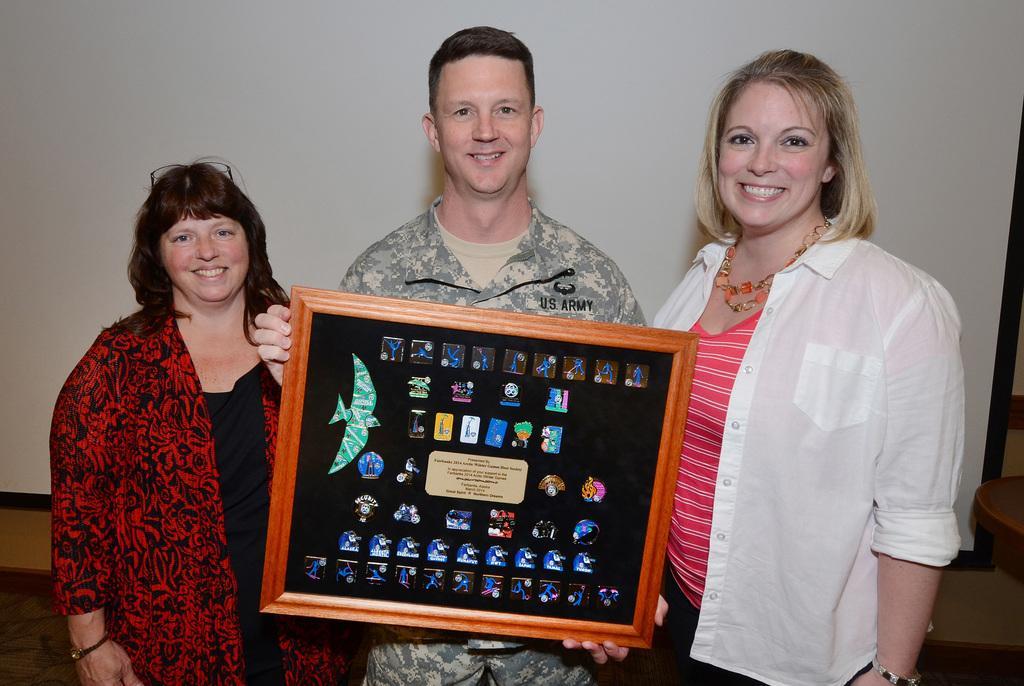Describe this image in one or two sentences. In this image there are three people standing and one person is holding a photo frame, and on the photo frame there are some images. And in the background there is a screen, and on the right side there is a table. At the bottom there is floor. 